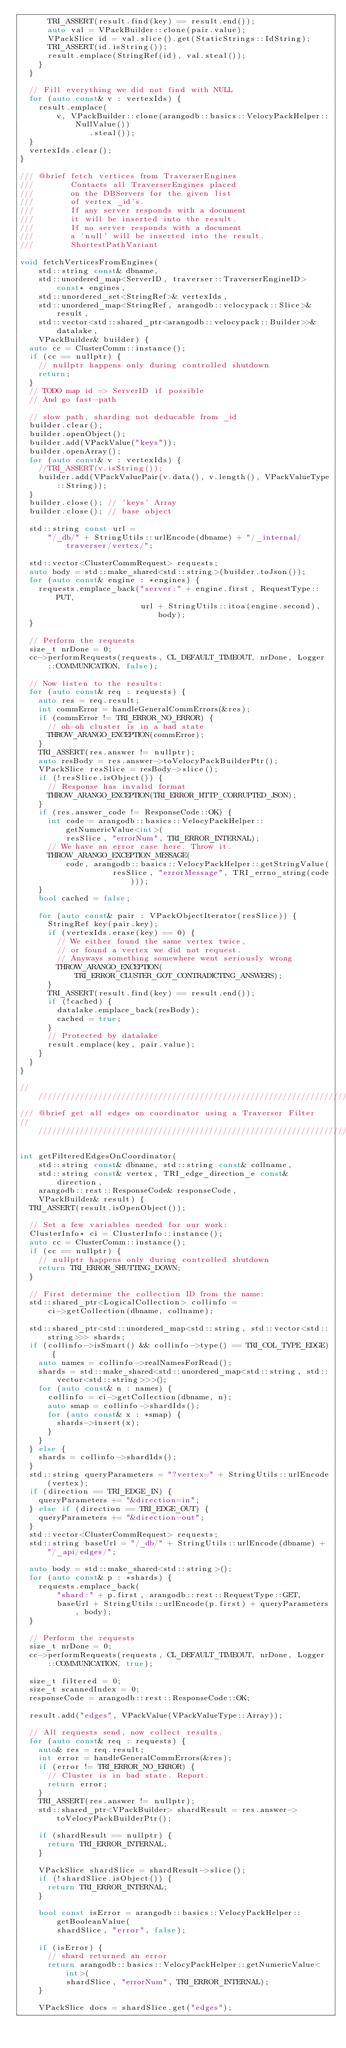Convert code to text. <code><loc_0><loc_0><loc_500><loc_500><_C++_>      TRI_ASSERT(result.find(key) == result.end());
      auto val = VPackBuilder::clone(pair.value);
      VPackSlice id = val.slice().get(StaticStrings::IdString);
      TRI_ASSERT(id.isString());
      result.emplace(StringRef(id), val.steal());
    }
  }

  // Fill everything we did not find with NULL
  for (auto const& v : vertexIds) {
    result.emplace(
        v, VPackBuilder::clone(arangodb::basics::VelocyPackHelper::NullValue())
               .steal());
  }
  vertexIds.clear();
}

/// @brief fetch vertices from TraverserEngines
///        Contacts all TraverserEngines placed
///        on the DBServers for the given list
///        of vertex _id's.
///        If any server responds with a document
///        it will be inserted into the result.
///        If no server responds with a document
///        a 'null' will be inserted into the result.
///        ShortestPathVariant

void fetchVerticesFromEngines(
    std::string const& dbname,
    std::unordered_map<ServerID, traverser::TraverserEngineID> const* engines,
    std::unordered_set<StringRef>& vertexIds,
    std::unordered_map<StringRef, arangodb::velocypack::Slice>& result,
    std::vector<std::shared_ptr<arangodb::velocypack::Builder>>& datalake,
    VPackBuilder& builder) {
  auto cc = ClusterComm::instance();
  if (cc == nullptr) {
    // nullptr happens only during controlled shutdown
    return;
  }
  // TODO map id => ServerID if possible
  // And go fast-path

  // slow path, sharding not deducable from _id
  builder.clear();
  builder.openObject();
  builder.add(VPackValue("keys"));
  builder.openArray();
  for (auto const& v : vertexIds) {
    //TRI_ASSERT(v.isString());
    builder.add(VPackValuePair(v.data(), v.length(), VPackValueType::String));
  }
  builder.close(); // 'keys' Array
  builder.close(); // base object

  std::string const url =
      "/_db/" + StringUtils::urlEncode(dbname) + "/_internal/traverser/vertex/";

  std::vector<ClusterCommRequest> requests;
  auto body = std::make_shared<std::string>(builder.toJson());
  for (auto const& engine : *engines) {
    requests.emplace_back("server:" + engine.first, RequestType::PUT,
                          url + StringUtils::itoa(engine.second), body);
  }

  // Perform the requests
  size_t nrDone = 0;
  cc->performRequests(requests, CL_DEFAULT_TIMEOUT, nrDone, Logger::COMMUNICATION, false);

  // Now listen to the results:
  for (auto const& req : requests) {
    auto res = req.result;
    int commError = handleGeneralCommErrors(&res);
    if (commError != TRI_ERROR_NO_ERROR) {
      // oh-oh cluster is in a bad state
      THROW_ARANGO_EXCEPTION(commError);
    }
    TRI_ASSERT(res.answer != nullptr);
    auto resBody = res.answer->toVelocyPackBuilderPtr();
    VPackSlice resSlice = resBody->slice();
    if (!resSlice.isObject()) {
      // Response has invalid format
      THROW_ARANGO_EXCEPTION(TRI_ERROR_HTTP_CORRUPTED_JSON);
    }
    if (res.answer_code != ResponseCode::OK) {
      int code = arangodb::basics::VelocyPackHelper::getNumericValue<int>(
          resSlice, "errorNum", TRI_ERROR_INTERNAL);
      // We have an error case here. Throw it.
      THROW_ARANGO_EXCEPTION_MESSAGE(
          code, arangodb::basics::VelocyPackHelper::getStringValue(
                    resSlice, "errorMessage", TRI_errno_string(code)));
    }
    bool cached = false;

    for (auto const& pair : VPackObjectIterator(resSlice)) {
      StringRef key(pair.key);
      if (vertexIds.erase(key) == 0) {
        // We either found the same vertex twice,
        // or found a vertex we did not request.
        // Anyways something somewhere went seriously wrong
        THROW_ARANGO_EXCEPTION(TRI_ERROR_CLUSTER_GOT_CONTRADICTING_ANSWERS);
      }
      TRI_ASSERT(result.find(key) == result.end());
      if (!cached) {
        datalake.emplace_back(resBody);
        cached = true;
      }
      // Protected by datalake
      result.emplace(key, pair.value);
    }
  }
}

////////////////////////////////////////////////////////////////////////////////
/// @brief get all edges on coordinator using a Traverser Filter
////////////////////////////////////////////////////////////////////////////////

int getFilteredEdgesOnCoordinator(
    std::string const& dbname, std::string const& collname,
    std::string const& vertex, TRI_edge_direction_e const& direction,
    arangodb::rest::ResponseCode& responseCode,
    VPackBuilder& result) {
  TRI_ASSERT(result.isOpenObject());

  // Set a few variables needed for our work:
  ClusterInfo* ci = ClusterInfo::instance();
  auto cc = ClusterComm::instance();
  if (cc == nullptr) {
    // nullptr happens only during controlled shutdown
    return TRI_ERROR_SHUTTING_DOWN;
  }

  // First determine the collection ID from the name:
  std::shared_ptr<LogicalCollection> collinfo =
      ci->getCollection(dbname, collname);

  std::shared_ptr<std::unordered_map<std::string, std::vector<std::string>>> shards;
  if (collinfo->isSmart() && collinfo->type() == TRI_COL_TYPE_EDGE) {
    auto names = collinfo->realNamesForRead();
    shards = std::make_shared<std::unordered_map<std::string, std::vector<std::string>>>();
    for (auto const& n : names) {
      collinfo = ci->getCollection(dbname, n);
      auto smap = collinfo->shardIds();
      for (auto const& x : *smap) {
        shards->insert(x);
      }
    }
  } else {
    shards = collinfo->shardIds();
  }
  std::string queryParameters = "?vertex=" + StringUtils::urlEncode(vertex);
  if (direction == TRI_EDGE_IN) {
    queryParameters += "&direction=in";
  } else if (direction == TRI_EDGE_OUT) {
    queryParameters += "&direction=out";
  }
  std::vector<ClusterCommRequest> requests;
  std::string baseUrl = "/_db/" + StringUtils::urlEncode(dbname) + "/_api/edges/";

  auto body = std::make_shared<std::string>();
  for (auto const& p : *shards) {
    requests.emplace_back(
        "shard:" + p.first, arangodb::rest::RequestType::GET,
        baseUrl + StringUtils::urlEncode(p.first) + queryParameters, body);
  }

  // Perform the requests
  size_t nrDone = 0;
  cc->performRequests(requests, CL_DEFAULT_TIMEOUT, nrDone, Logger::COMMUNICATION, true);

  size_t filtered = 0;
  size_t scannedIndex = 0;
  responseCode = arangodb::rest::ResponseCode::OK;

  result.add("edges", VPackValue(VPackValueType::Array));

  // All requests send, now collect results.
  for (auto const& req : requests) {
    auto& res = req.result;
    int error = handleGeneralCommErrors(&res);
    if (error != TRI_ERROR_NO_ERROR) {
      // Cluster is in bad state. Report.
      return error;
    }
    TRI_ASSERT(res.answer != nullptr);
    std::shared_ptr<VPackBuilder> shardResult = res.answer->toVelocyPackBuilderPtr();

    if (shardResult == nullptr) {
      return TRI_ERROR_INTERNAL;
    }

    VPackSlice shardSlice = shardResult->slice();
    if (!shardSlice.isObject()) {
      return TRI_ERROR_INTERNAL;
    }

    bool const isError = arangodb::basics::VelocyPackHelper::getBooleanValue(
        shardSlice, "error", false);

    if (isError) {
      // shard returned an error
      return arangodb::basics::VelocyPackHelper::getNumericValue<int>(
          shardSlice, "errorNum", TRI_ERROR_INTERNAL);
    }

    VPackSlice docs = shardSlice.get("edges");
</code> 